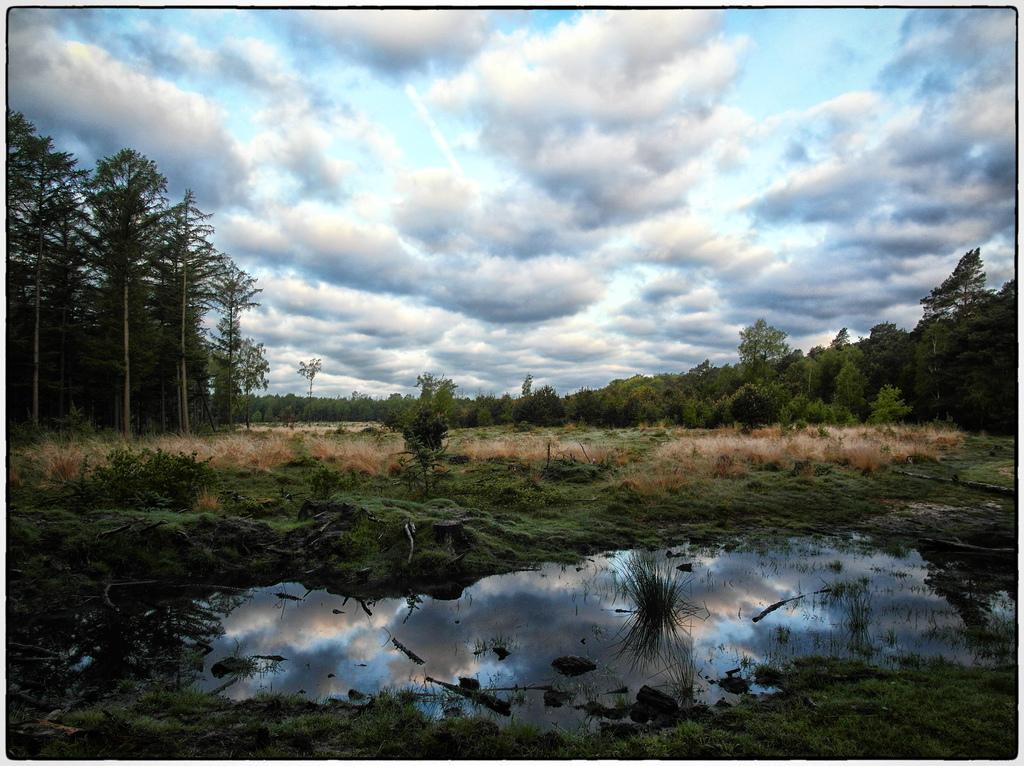Describe this image in one or two sentences. This is an outside view. At the bottom of the image I can see the water. Around the water I can see the grass in green color. In the background there are some trees. On the top of the image I can see the sky and it is cloudy. 